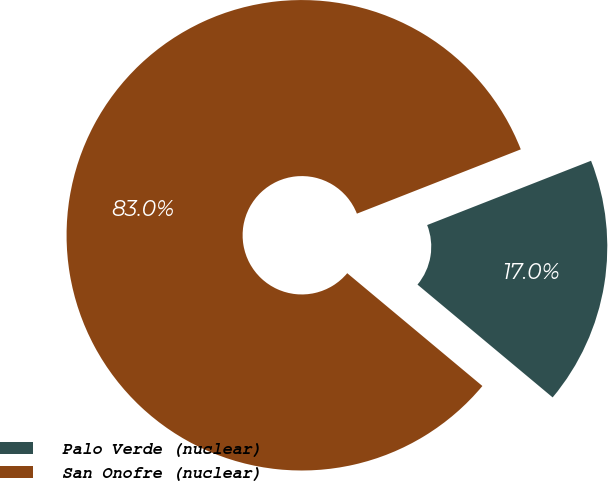Convert chart. <chart><loc_0><loc_0><loc_500><loc_500><pie_chart><fcel>Palo Verde (nuclear)<fcel>San Onofre (nuclear)<nl><fcel>17.02%<fcel>82.98%<nl></chart> 